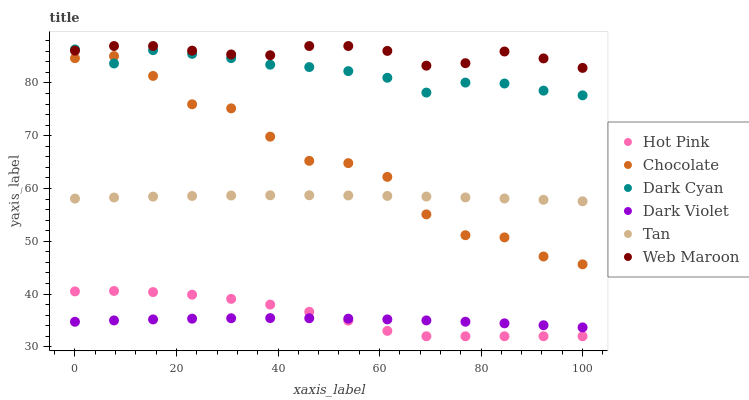Does Dark Violet have the minimum area under the curve?
Answer yes or no. Yes. Does Web Maroon have the maximum area under the curve?
Answer yes or no. Yes. Does Web Maroon have the minimum area under the curve?
Answer yes or no. No. Does Dark Violet have the maximum area under the curve?
Answer yes or no. No. Is Tan the smoothest?
Answer yes or no. Yes. Is Chocolate the roughest?
Answer yes or no. Yes. Is Web Maroon the smoothest?
Answer yes or no. No. Is Web Maroon the roughest?
Answer yes or no. No. Does Hot Pink have the lowest value?
Answer yes or no. Yes. Does Dark Violet have the lowest value?
Answer yes or no. No. Does Web Maroon have the highest value?
Answer yes or no. Yes. Does Dark Violet have the highest value?
Answer yes or no. No. Is Hot Pink less than Tan?
Answer yes or no. Yes. Is Dark Cyan greater than Tan?
Answer yes or no. Yes. Does Dark Violet intersect Hot Pink?
Answer yes or no. Yes. Is Dark Violet less than Hot Pink?
Answer yes or no. No. Is Dark Violet greater than Hot Pink?
Answer yes or no. No. Does Hot Pink intersect Tan?
Answer yes or no. No. 